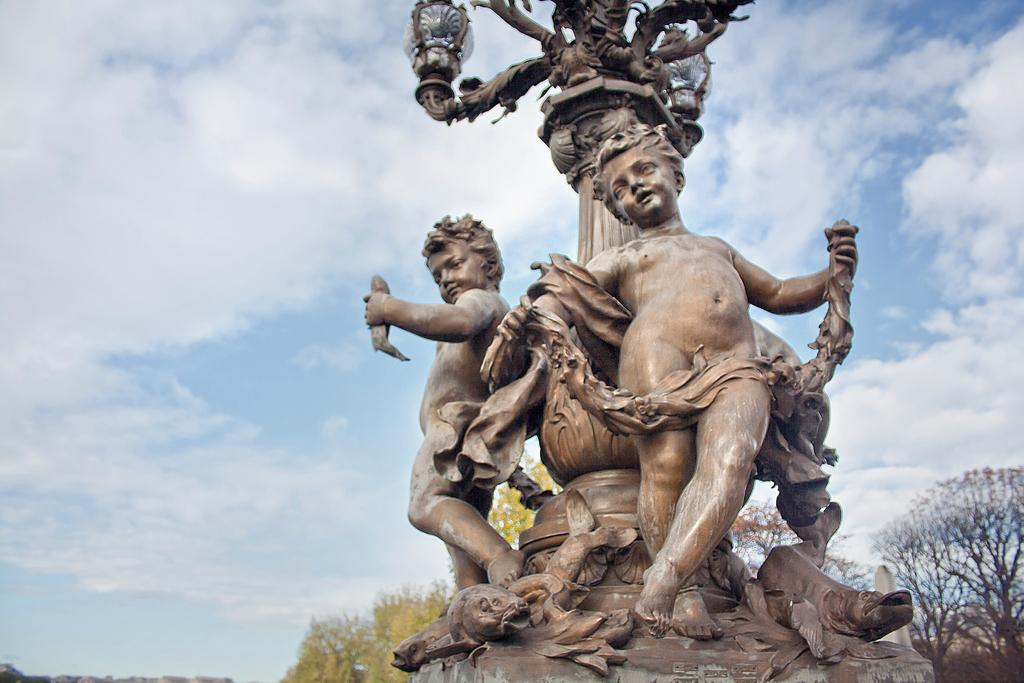What type of art is present in the image? There are sculptures in the image. What color are the sculptures? The sculptures are brown in color. What can be seen in the background of the image? There are trees and the sky visible in the background of the image. How many trucks are parked next to the sculptures in the image? There are no trucks present in the image; it only features sculptures, trees, and the sky. 